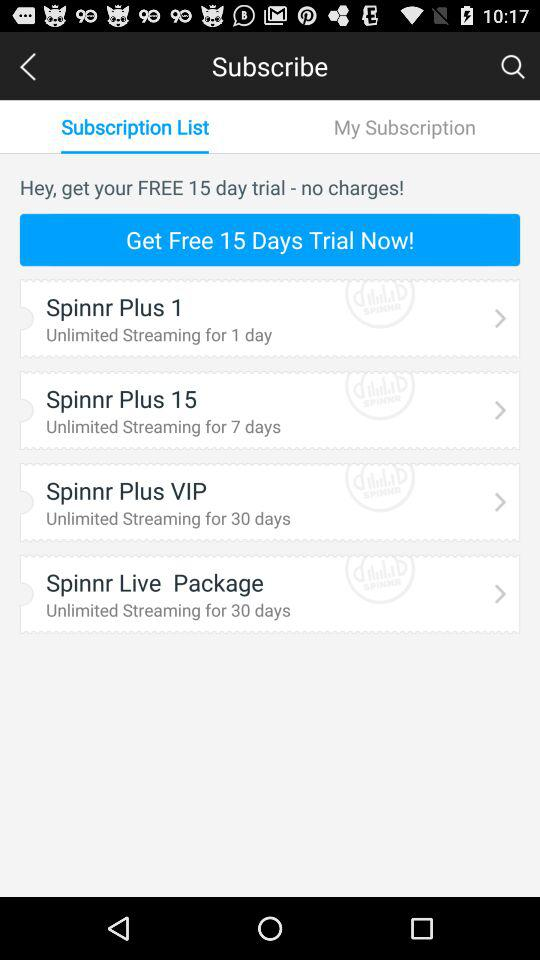What are the different items in the subscription list? The different items are "Spinnr Plus 1", "Spinnr Plus 15", "Spinnr Plus VIP", and "Spinnr Live Package". 